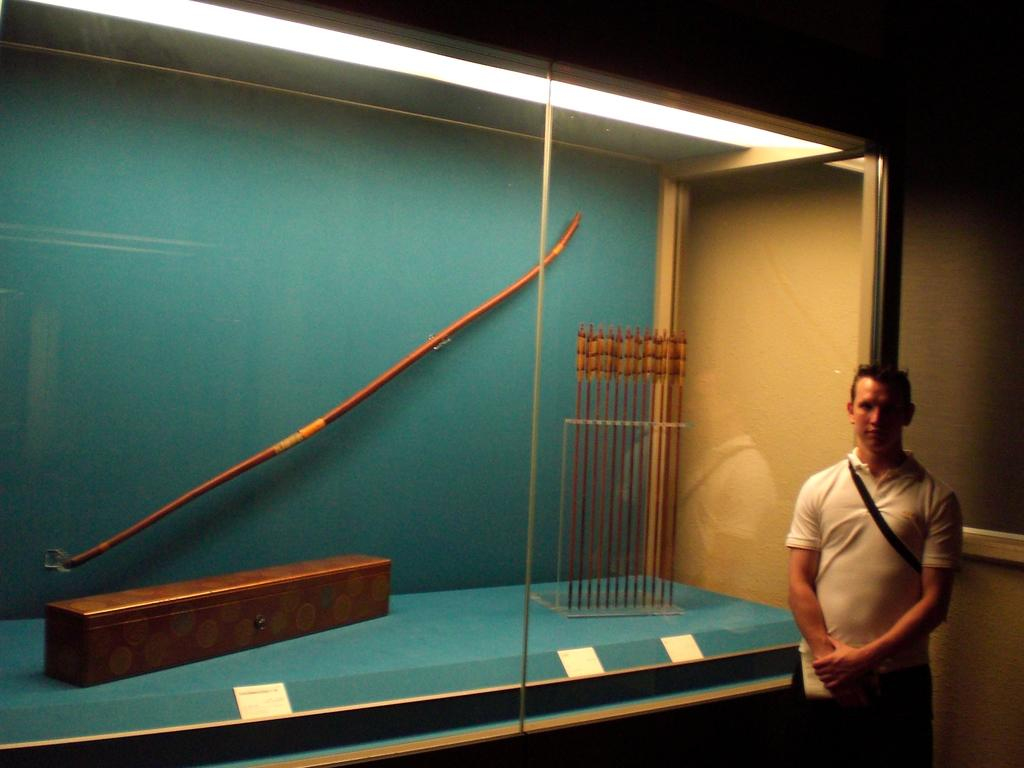Who is present in the image? There is a man in the image. Where is the man located in the image? The man is in the right corner of the image. What is the man wearing? The man is wearing a white t-shirt. What is the man standing beside? The man is standing beside a glass. What can be found inside the glass? There is a box and arrows in the glass. What else is in the glass? There is a stick in the glass. What type of peace symbol can be seen in the image? There is no peace symbol present in the image. What type of eggnog is being served in the glass? There is no eggnog present in the image; it contains a box, arrows, and a stick. 